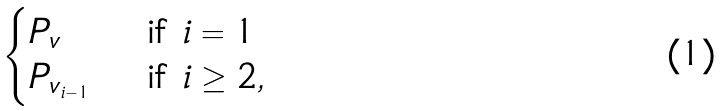Convert formula to latex. <formula><loc_0><loc_0><loc_500><loc_500>\begin{cases} P _ { v } & \text { if $i=1$} \\ P _ { v _ { i - 1 } } & \text { if $i \geq 2$} , \end{cases}</formula> 